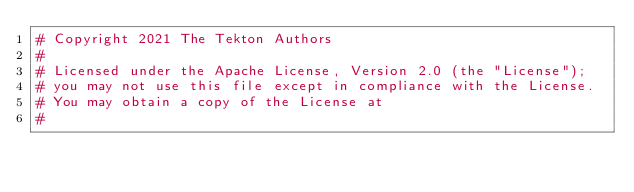Convert code to text. <code><loc_0><loc_0><loc_500><loc_500><_Python_># Copyright 2021 The Tekton Authors
#
# Licensed under the Apache License, Version 2.0 (the "License");
# you may not use this file except in compliance with the License.
# You may obtain a copy of the License at
#</code> 